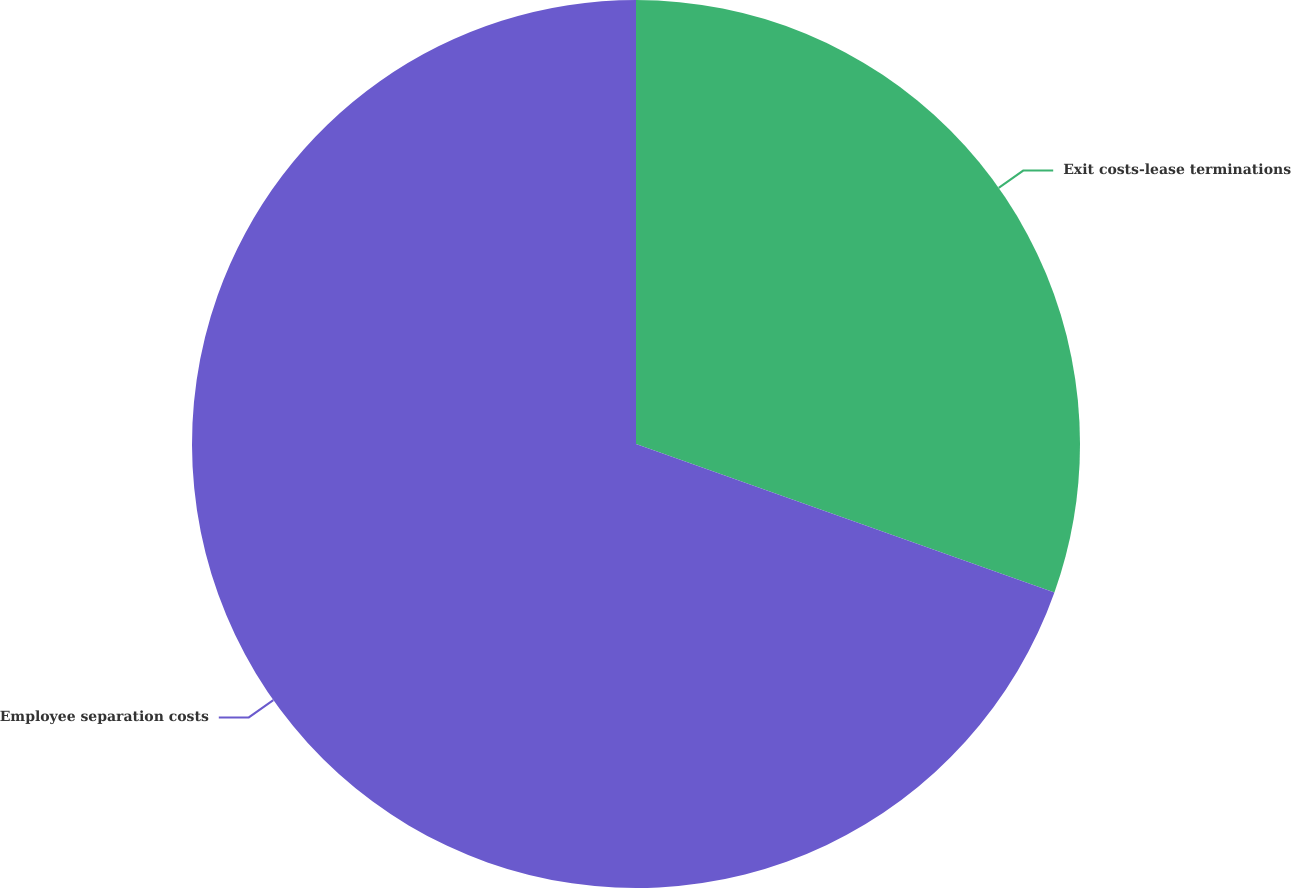Convert chart. <chart><loc_0><loc_0><loc_500><loc_500><pie_chart><fcel>Exit costs-lease terminations<fcel>Employee separation costs<nl><fcel>30.43%<fcel>69.57%<nl></chart> 